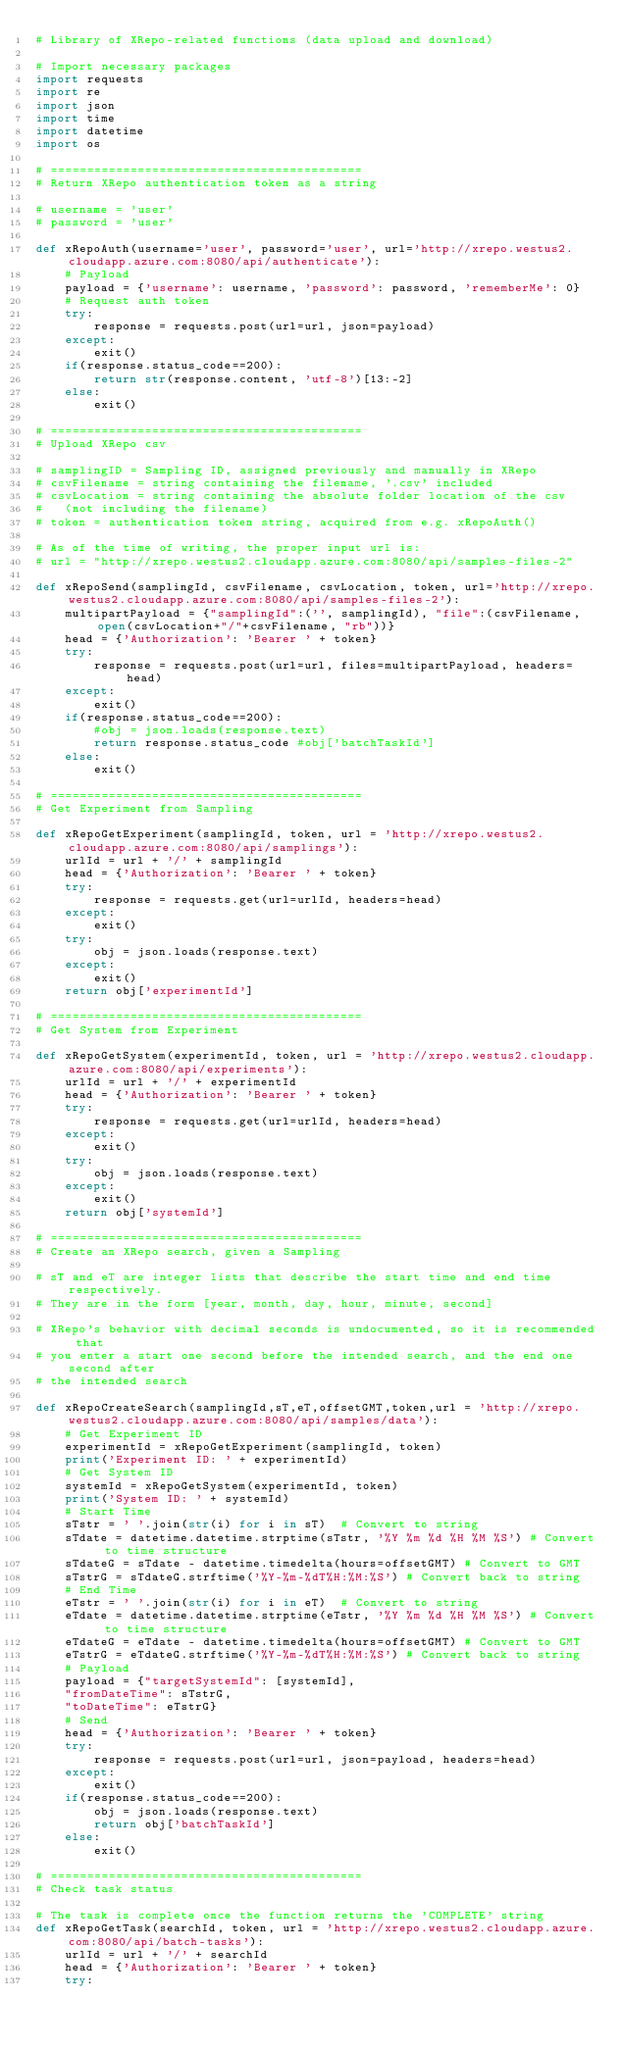Convert code to text. <code><loc_0><loc_0><loc_500><loc_500><_Python_># Library of XRepo-related functions (data upload and download)

# Import necessary packages
import requests
import re
import json
import time
import datetime
import os

# ===========================================
# Return XRepo authentication token as a string

# username = 'user'
# password = 'user'

def xRepoAuth(username='user', password='user', url='http://xrepo.westus2.cloudapp.azure.com:8080/api/authenticate'):
    # Payload
    payload = {'username': username, 'password': password, 'rememberMe': 0}
    # Request auth token
    try:
        response = requests.post(url=url, json=payload)
    except:
        exit()
    if(response.status_code==200):
        return str(response.content, 'utf-8')[13:-2]
    else:
        exit()

# ===========================================
# Upload XRepo csv

# samplingID = Sampling ID, assigned previously and manually in XRepo
# csvFilename = string containing the filename, '.csv' included
# csvLocation = string containing the absolute folder location of the csv
#   (not including the filename)
# token = authentication token string, acquired from e.g. xRepoAuth()

# As of the time of writing, the proper input url is:
# url = "http://xrepo.westus2.cloudapp.azure.com:8080/api/samples-files-2"

def xRepoSend(samplingId, csvFilename, csvLocation, token, url='http://xrepo.westus2.cloudapp.azure.com:8080/api/samples-files-2'):
    multipartPayload = {"samplingId":('', samplingId), "file":(csvFilename, open(csvLocation+"/"+csvFilename, "rb"))}
    head = {'Authorization': 'Bearer ' + token}
    try:
        response = requests.post(url=url, files=multipartPayload, headers=head)
    except:
        exit()
    if(response.status_code==200):
        #obj = json.loads(response.text)
        return response.status_code #obj['batchTaskId']
    else:
        exit()

# ===========================================
# Get Experiment from Sampling

def xRepoGetExperiment(samplingId, token, url = 'http://xrepo.westus2.cloudapp.azure.com:8080/api/samplings'):
    urlId = url + '/' + samplingId
    head = {'Authorization': 'Bearer ' + token}
    try:
        response = requests.get(url=urlId, headers=head)
    except:
        exit()
    try:
        obj = json.loads(response.text)
    except:
        exit()
    return obj['experimentId']

# ===========================================
# Get System from Experiment

def xRepoGetSystem(experimentId, token, url = 'http://xrepo.westus2.cloudapp.azure.com:8080/api/experiments'):
    urlId = url + '/' + experimentId
    head = {'Authorization': 'Bearer ' + token}
    try:
        response = requests.get(url=urlId, headers=head)
    except:
        exit()
    try:
        obj = json.loads(response.text)
    except:
        exit()
    return obj['systemId']

# ===========================================
# Create an XRepo search, given a Sampling

# sT and eT are integer lists that describe the start time and end time respectively.
# They are in the form [year, month, day, hour, minute, second]

# XRepo's behavior with decimal seconds is undocumented, so it is recommended that
# you enter a start one second before the intended search, and the end one second after
# the intended search

def xRepoCreateSearch(samplingId,sT,eT,offsetGMT,token,url = 'http://xrepo.westus2.cloudapp.azure.com:8080/api/samples/data'):
    # Get Experiment ID
    experimentId = xRepoGetExperiment(samplingId, token)
    print('Experiment ID: ' + experimentId)
    # Get System ID
    systemId = xRepoGetSystem(experimentId, token)
    print('System ID: ' + systemId)
    # Start Time
    sTstr = ' '.join(str(i) for i in sT)  # Convert to string
    sTdate = datetime.datetime.strptime(sTstr, '%Y %m %d %H %M %S') # Convert to time structure
    sTdateG = sTdate - datetime.timedelta(hours=offsetGMT) # Convert to GMT
    sTstrG = sTdateG.strftime('%Y-%m-%dT%H:%M:%S') # Convert back to string
    # End Time
    eTstr = ' '.join(str(i) for i in eT)  # Convert to string
    eTdate = datetime.datetime.strptime(eTstr, '%Y %m %d %H %M %S') # Convert to time structure
    eTdateG = eTdate - datetime.timedelta(hours=offsetGMT) # Convert to GMT
    eTstrG = eTdateG.strftime('%Y-%m-%dT%H:%M:%S') # Convert back to string
    # Payload
    payload = {"targetSystemId": [systemId],
    "fromDateTime": sTstrG,
    "toDateTime": eTstrG}
    # Send
    head = {'Authorization': 'Bearer ' + token}
    try:
        response = requests.post(url=url, json=payload, headers=head)
    except:
        exit()
    if(response.status_code==200):
        obj = json.loads(response.text)
        return obj['batchTaskId']
    else:
        exit()

# ===========================================
# Check task status

# The task is complete once the function returns the 'COMPLETE' string
def xRepoGetTask(searchId, token, url = 'http://xrepo.westus2.cloudapp.azure.com:8080/api/batch-tasks'):
    urlId = url + '/' + searchId
    head = {'Authorization': 'Bearer ' + token}
    try:</code> 